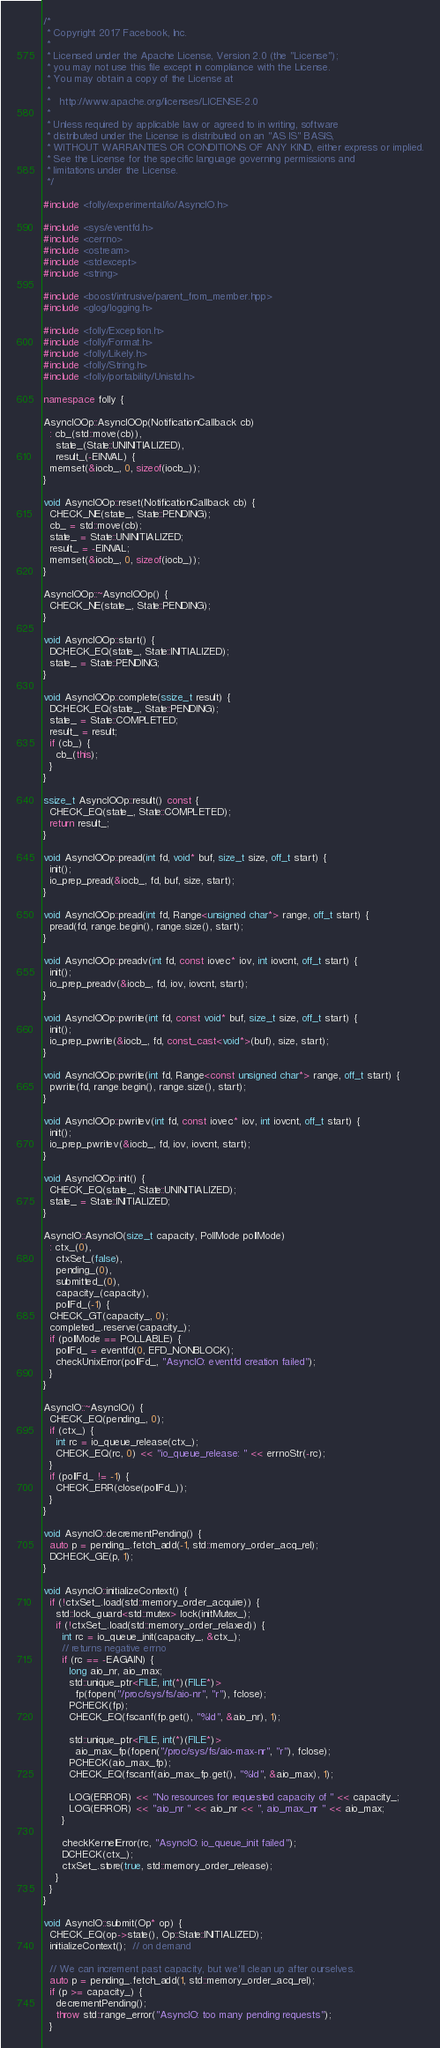<code> <loc_0><loc_0><loc_500><loc_500><_C++_>/*
 * Copyright 2017 Facebook, Inc.
 *
 * Licensed under the Apache License, Version 2.0 (the "License");
 * you may not use this file except in compliance with the License.
 * You may obtain a copy of the License at
 *
 *   http://www.apache.org/licenses/LICENSE-2.0
 *
 * Unless required by applicable law or agreed to in writing, software
 * distributed under the License is distributed on an "AS IS" BASIS,
 * WITHOUT WARRANTIES OR CONDITIONS OF ANY KIND, either express or implied.
 * See the License for the specific language governing permissions and
 * limitations under the License.
 */

#include <folly/experimental/io/AsyncIO.h>

#include <sys/eventfd.h>
#include <cerrno>
#include <ostream>
#include <stdexcept>
#include <string>

#include <boost/intrusive/parent_from_member.hpp>
#include <glog/logging.h>

#include <folly/Exception.h>
#include <folly/Format.h>
#include <folly/Likely.h>
#include <folly/String.h>
#include <folly/portability/Unistd.h>

namespace folly {

AsyncIOOp::AsyncIOOp(NotificationCallback cb)
  : cb_(std::move(cb)),
    state_(State::UNINITIALIZED),
    result_(-EINVAL) {
  memset(&iocb_, 0, sizeof(iocb_));
}

void AsyncIOOp::reset(NotificationCallback cb) {
  CHECK_NE(state_, State::PENDING);
  cb_ = std::move(cb);
  state_ = State::UNINITIALIZED;
  result_ = -EINVAL;
  memset(&iocb_, 0, sizeof(iocb_));
}

AsyncIOOp::~AsyncIOOp() {
  CHECK_NE(state_, State::PENDING);
}

void AsyncIOOp::start() {
  DCHECK_EQ(state_, State::INITIALIZED);
  state_ = State::PENDING;
}

void AsyncIOOp::complete(ssize_t result) {
  DCHECK_EQ(state_, State::PENDING);
  state_ = State::COMPLETED;
  result_ = result;
  if (cb_) {
    cb_(this);
  }
}

ssize_t AsyncIOOp::result() const {
  CHECK_EQ(state_, State::COMPLETED);
  return result_;
}

void AsyncIOOp::pread(int fd, void* buf, size_t size, off_t start) {
  init();
  io_prep_pread(&iocb_, fd, buf, size, start);
}

void AsyncIOOp::pread(int fd, Range<unsigned char*> range, off_t start) {
  pread(fd, range.begin(), range.size(), start);
}

void AsyncIOOp::preadv(int fd, const iovec* iov, int iovcnt, off_t start) {
  init();
  io_prep_preadv(&iocb_, fd, iov, iovcnt, start);
}

void AsyncIOOp::pwrite(int fd, const void* buf, size_t size, off_t start) {
  init();
  io_prep_pwrite(&iocb_, fd, const_cast<void*>(buf), size, start);
}

void AsyncIOOp::pwrite(int fd, Range<const unsigned char*> range, off_t start) {
  pwrite(fd, range.begin(), range.size(), start);
}

void AsyncIOOp::pwritev(int fd, const iovec* iov, int iovcnt, off_t start) {
  init();
  io_prep_pwritev(&iocb_, fd, iov, iovcnt, start);
}

void AsyncIOOp::init() {
  CHECK_EQ(state_, State::UNINITIALIZED);
  state_ = State::INITIALIZED;
}

AsyncIO::AsyncIO(size_t capacity, PollMode pollMode)
  : ctx_(0),
    ctxSet_(false),
    pending_(0),
    submitted_(0),
    capacity_(capacity),
    pollFd_(-1) {
  CHECK_GT(capacity_, 0);
  completed_.reserve(capacity_);
  if (pollMode == POLLABLE) {
    pollFd_ = eventfd(0, EFD_NONBLOCK);
    checkUnixError(pollFd_, "AsyncIO: eventfd creation failed");
  }
}

AsyncIO::~AsyncIO() {
  CHECK_EQ(pending_, 0);
  if (ctx_) {
    int rc = io_queue_release(ctx_);
    CHECK_EQ(rc, 0) << "io_queue_release: " << errnoStr(-rc);
  }
  if (pollFd_ != -1) {
    CHECK_ERR(close(pollFd_));
  }
}

void AsyncIO::decrementPending() {
  auto p = pending_.fetch_add(-1, std::memory_order_acq_rel);
  DCHECK_GE(p, 1);
}

void AsyncIO::initializeContext() {
  if (!ctxSet_.load(std::memory_order_acquire)) {
    std::lock_guard<std::mutex> lock(initMutex_);
    if (!ctxSet_.load(std::memory_order_relaxed)) {
      int rc = io_queue_init(capacity_, &ctx_);
      // returns negative errno
      if (rc == -EAGAIN) {
        long aio_nr, aio_max;
        std::unique_ptr<FILE, int(*)(FILE*)>
          fp(fopen("/proc/sys/fs/aio-nr", "r"), fclose);
        PCHECK(fp);
        CHECK_EQ(fscanf(fp.get(), "%ld", &aio_nr), 1);

        std::unique_ptr<FILE, int(*)(FILE*)>
          aio_max_fp(fopen("/proc/sys/fs/aio-max-nr", "r"), fclose);
        PCHECK(aio_max_fp);
        CHECK_EQ(fscanf(aio_max_fp.get(), "%ld", &aio_max), 1);

        LOG(ERROR) << "No resources for requested capacity of " << capacity_;
        LOG(ERROR) << "aio_nr " << aio_nr << ", aio_max_nr " << aio_max;
      }

      checkKernelError(rc, "AsyncIO: io_queue_init failed");
      DCHECK(ctx_);
      ctxSet_.store(true, std::memory_order_release);
    }
  }
}

void AsyncIO::submit(Op* op) {
  CHECK_EQ(op->state(), Op::State::INITIALIZED);
  initializeContext();  // on demand

  // We can increment past capacity, but we'll clean up after ourselves.
  auto p = pending_.fetch_add(1, std::memory_order_acq_rel);
  if (p >= capacity_) {
    decrementPending();
    throw std::range_error("AsyncIO: too many pending requests");
  }</code> 